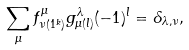<formula> <loc_0><loc_0><loc_500><loc_500>\sum _ { \mu } f ^ { \mu } _ { \nu ( 1 ^ { k } ) } g ^ { \lambda } _ { \mu ( l ) } ( - 1 ) ^ { l } = \delta _ { \lambda , \nu } ,</formula> 